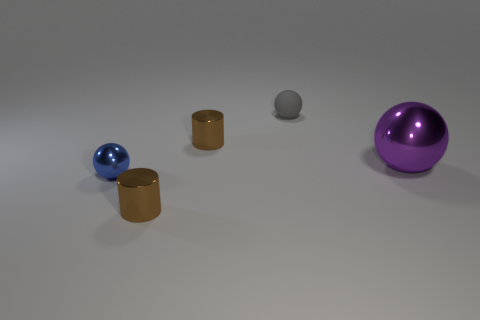Is there anything else that is the same size as the purple ball?
Give a very brief answer. No. There is a brown cylinder in front of the big purple ball; is its size the same as the ball behind the large purple thing?
Keep it short and to the point. Yes. There is a cylinder that is in front of the small blue shiny ball; what is its size?
Your answer should be compact. Small. Are there any cylinders that have the same color as the matte sphere?
Offer a very short reply. No. There is a shiny ball to the left of the tiny rubber object; are there any objects in front of it?
Offer a terse response. Yes. There is a gray object; is its size the same as the blue sphere that is on the left side of the small gray object?
Ensure brevity in your answer.  Yes. Are there any blue spheres that are in front of the metal cylinder that is on the left side of the tiny brown cylinder behind the purple metallic ball?
Your response must be concise. No. What material is the small brown cylinder that is behind the blue shiny sphere?
Provide a succinct answer. Metal. Is the purple metallic sphere the same size as the blue ball?
Offer a very short reply. No. What color is the tiny thing that is in front of the rubber thing and behind the small blue metallic ball?
Offer a very short reply. Brown. 